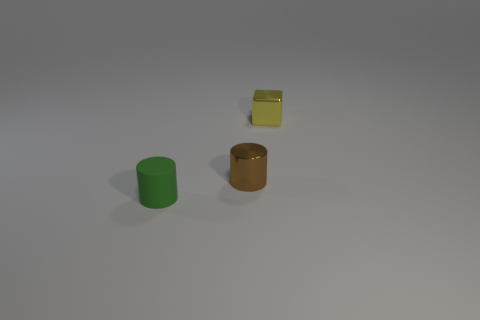The rubber object is what size?
Provide a short and direct response. Small. Is the size of the metal cylinder the same as the object right of the brown shiny object?
Give a very brief answer. Yes. What number of green things are tiny metallic things or small matte cylinders?
Make the answer very short. 1. How many metal balls are there?
Your answer should be very brief. 0. There is a cylinder to the right of the green matte thing; how big is it?
Give a very brief answer. Small. Do the metal cylinder and the green matte object have the same size?
Keep it short and to the point. Yes. What number of objects are either small rubber things or tiny objects on the left side of the brown metallic thing?
Your answer should be very brief. 1. What material is the green cylinder?
Offer a very short reply. Rubber. Are there any other things that are the same color as the small block?
Your response must be concise. No. Do the tiny yellow object and the tiny brown metal thing have the same shape?
Offer a terse response. No. 